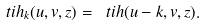Convert formula to latex. <formula><loc_0><loc_0><loc_500><loc_500>\ t i h _ { k } ( u , v , z ) = \ t i h ( u - k , v , z ) .</formula> 